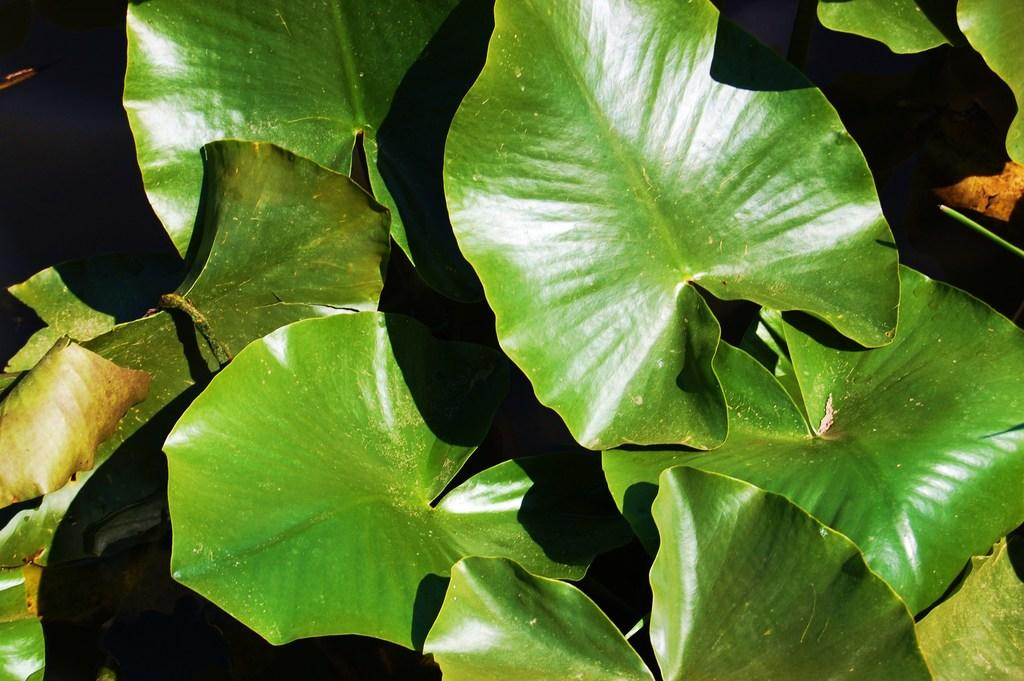What is visible in the foreground of the image? There are leaves of plants in the foreground of the image. What type of voice can be heard coming from the straw in the image? There is no straw present in the image, and therefore no voice can be heard coming from it. 